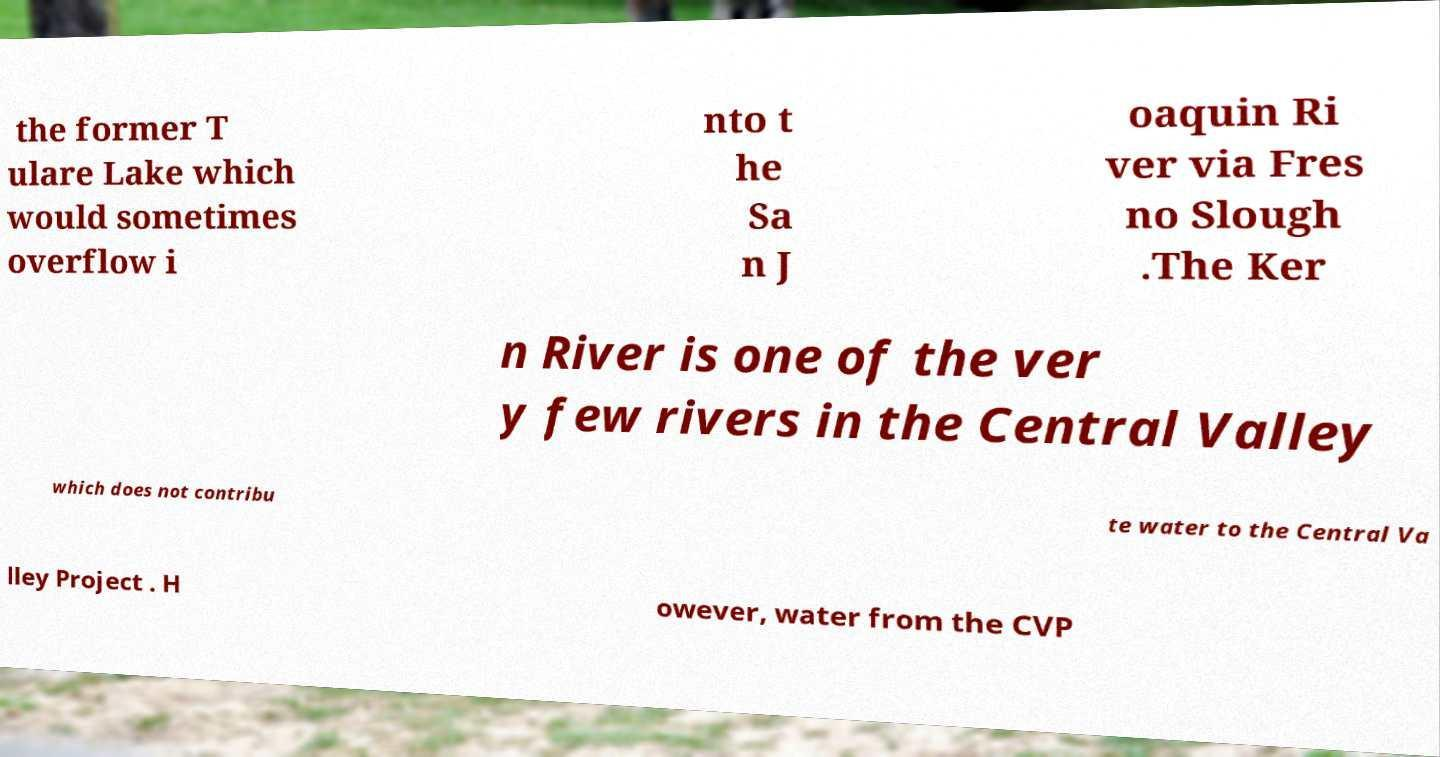There's text embedded in this image that I need extracted. Can you transcribe it verbatim? the former T ulare Lake which would sometimes overflow i nto t he Sa n J oaquin Ri ver via Fres no Slough .The Ker n River is one of the ver y few rivers in the Central Valley which does not contribu te water to the Central Va lley Project . H owever, water from the CVP 